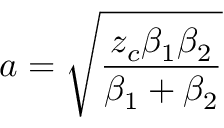Convert formula to latex. <formula><loc_0><loc_0><loc_500><loc_500>a = \sqrt { \frac { z _ { c } \beta _ { 1 } \beta _ { 2 } } { \beta _ { 1 } + \beta _ { 2 } } }</formula> 